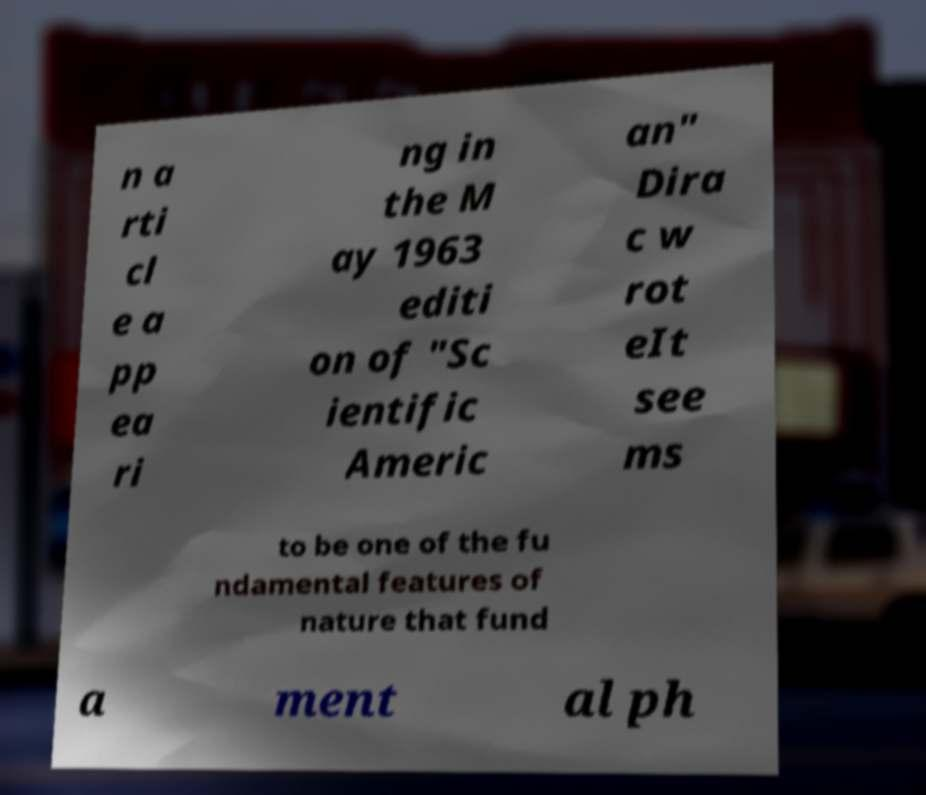For documentation purposes, I need the text within this image transcribed. Could you provide that? n a rti cl e a pp ea ri ng in the M ay 1963 editi on of "Sc ientific Americ an" Dira c w rot eIt see ms to be one of the fu ndamental features of nature that fund a ment al ph 